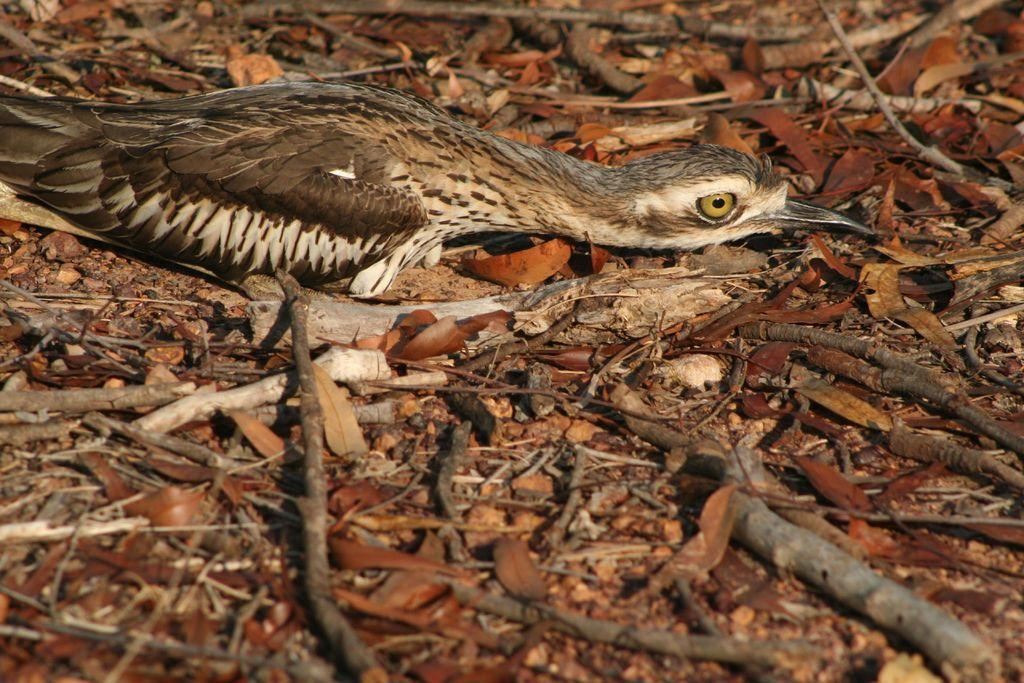What type of surface is visible in the image? There is ground visible in the image. What can be found on the ground in the image? There are leaves on the ground. What objects are made of wood in the image? There are wooden sticks in the image. What type of animal is present in the image? There is a bird in the image. Can you describe the bird's coloring? The bird has brown, cream, and black coloring. What type of sign can be seen hanging from the bird's beak in the image? There is no sign present in the image, and the bird's beak is not shown holding anything. 